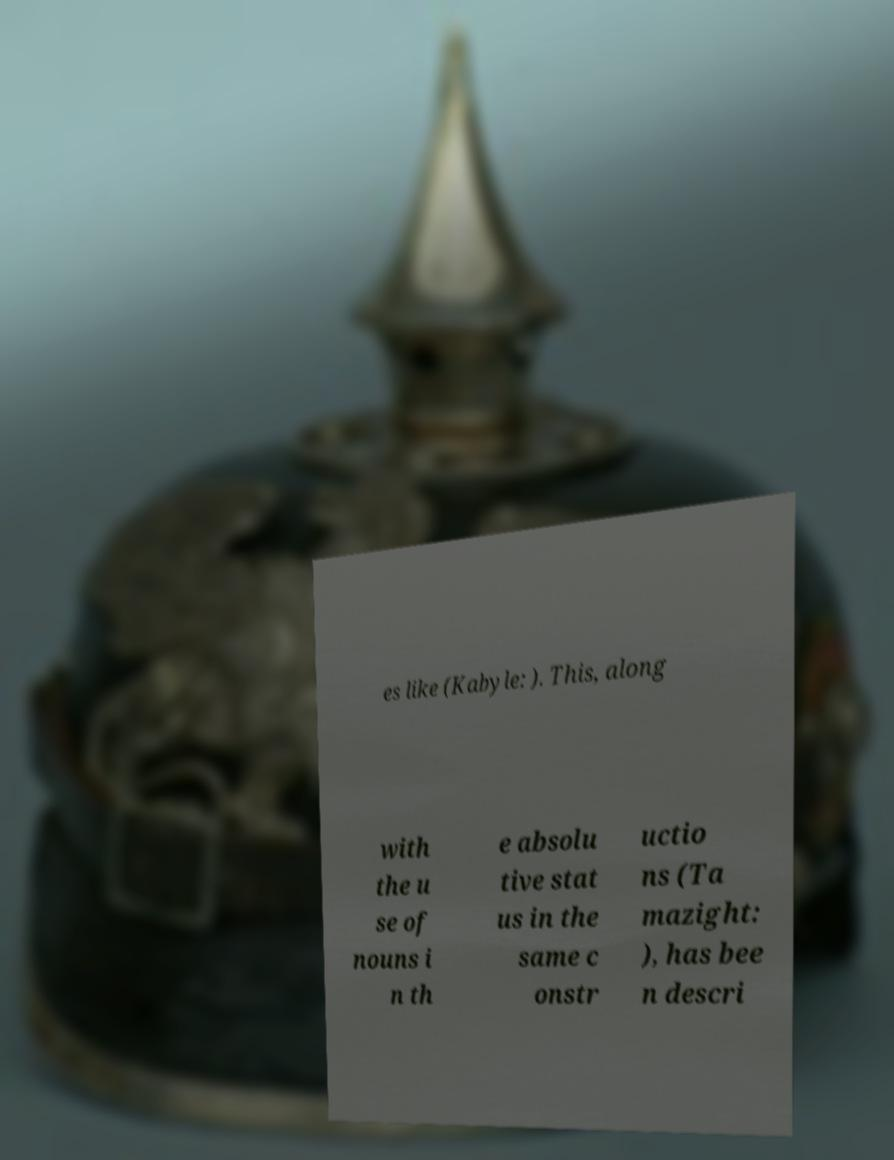Could you assist in decoding the text presented in this image and type it out clearly? es like (Kabyle: ). This, along with the u se of nouns i n th e absolu tive stat us in the same c onstr uctio ns (Ta mazight: ), has bee n descri 